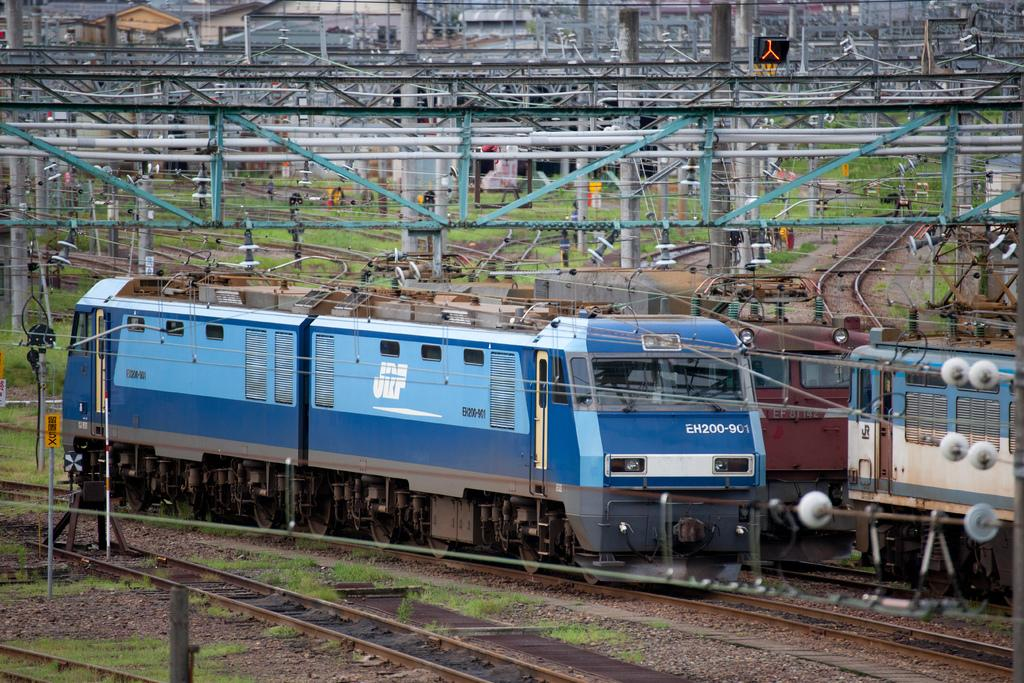<image>
Describe the image concisely. Train EH200-901 is blue and is in a busy train yard. 